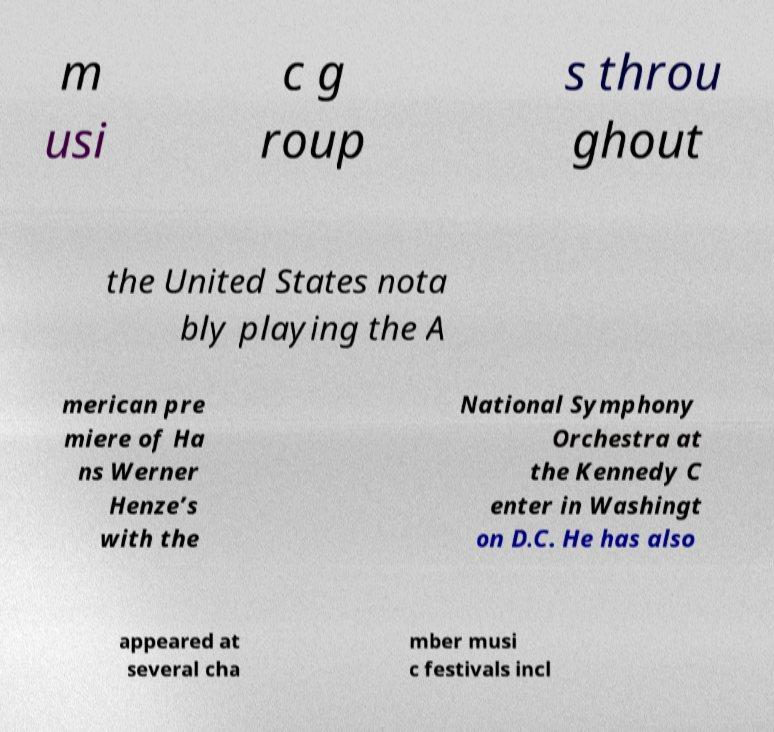Could you assist in decoding the text presented in this image and type it out clearly? m usi c g roup s throu ghout the United States nota bly playing the A merican pre miere of Ha ns Werner Henze’s with the National Symphony Orchestra at the Kennedy C enter in Washingt on D.C. He has also appeared at several cha mber musi c festivals incl 